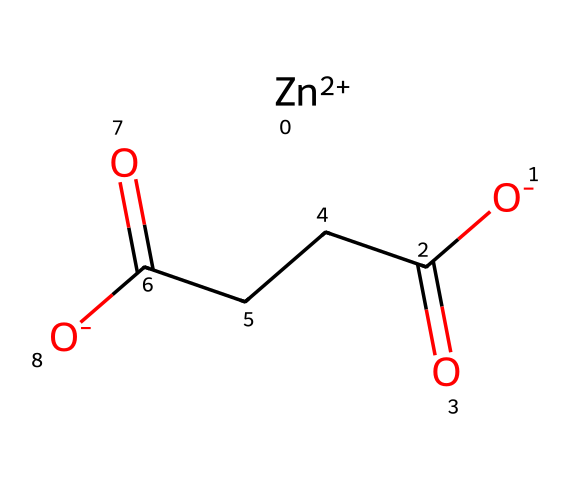What is the central atom in this compound? The central atom is zinc, which is identified as [Zn+2] in the SMILES representation. It indicates that zinc has a +2 oxidation state and is central to the molecular structure.
Answer: zinc How many oxygen atoms are present? The SMILES notation contains two instances of "O" indicating the presence of two oxygen atoms (both in the carboxyl groups).
Answer: two What type of bonds are present between the carbon and oxygen atoms? The bonds between the carbon and oxygen atoms are double bonds, as indicated by the "C(=O)" notation in the SMILES representation. This notation shows that the carbon is bonded to oxygen with a double bond.
Answer: double bonds What functional groups are identified in this compound? The compound features carboxyl groups, as shown by the "C(=O)[O-]" components; carboxyl groups are characteristic of organic acids.
Answer: carboxyl groups How many carbon atoms are in the structure? By analyzing the SMILES representation, there are five carbon atoms (the three from "CCC" and two from the carboxyl groups).
Answer: five What is the charge of the zinc ion in this compound? The zinc ion is represented as [Zn+2], indicating it has a +2 charge in this particular molecular structure.
Answer: +2 Which elements present are essential for eye health? Zinc is the key element in this compound that is known to support eye health and is commonly included in eye health supplements.
Answer: zinc 